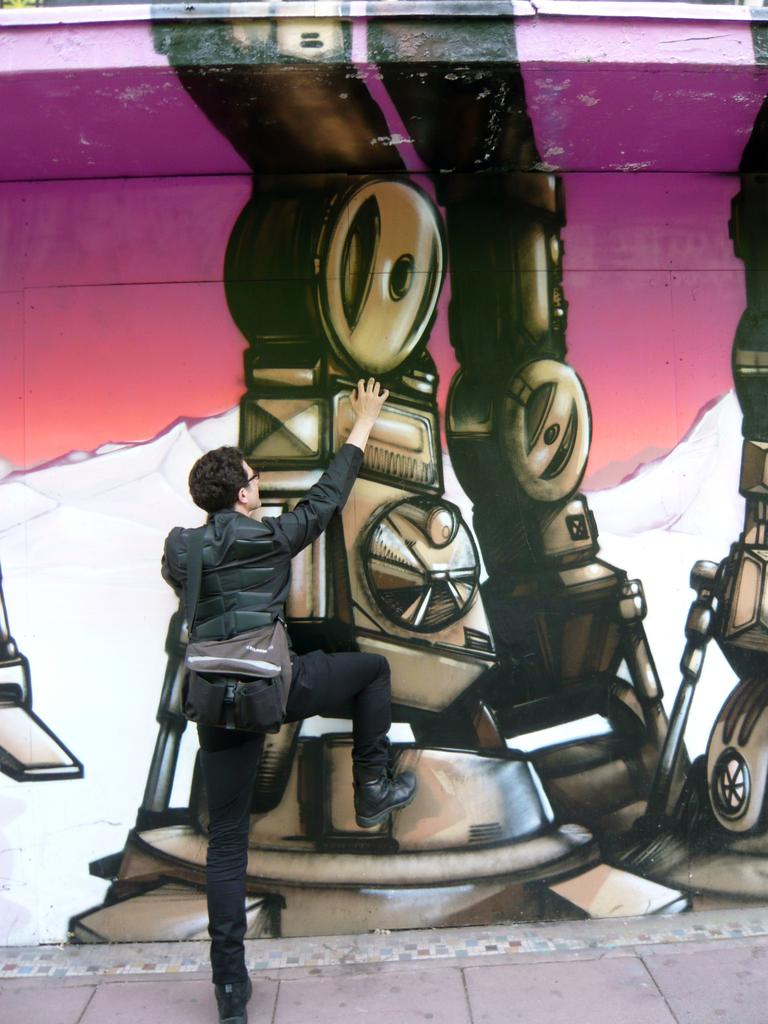What is the main subject in the image? There is a person standing on the footpath in the image. What else can be seen in the background of the image? There is a painting on the wall in the image. How many sisters are depicted in the painting on the wall? There is no painting of sisters in the image; the painting's content is not mentioned in the provided facts. 